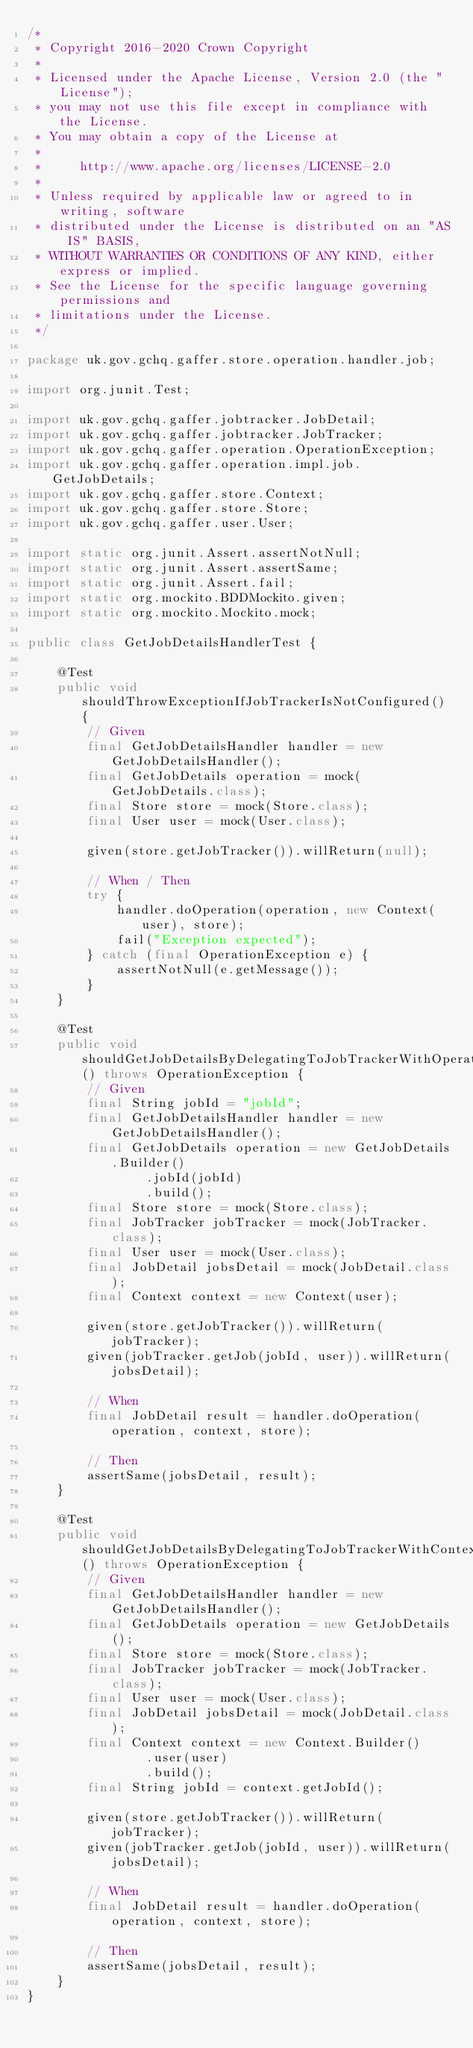Convert code to text. <code><loc_0><loc_0><loc_500><loc_500><_Java_>/*
 * Copyright 2016-2020 Crown Copyright
 *
 * Licensed under the Apache License, Version 2.0 (the "License");
 * you may not use this file except in compliance with the License.
 * You may obtain a copy of the License at
 *
 *     http://www.apache.org/licenses/LICENSE-2.0
 *
 * Unless required by applicable law or agreed to in writing, software
 * distributed under the License is distributed on an "AS IS" BASIS,
 * WITHOUT WARRANTIES OR CONDITIONS OF ANY KIND, either express or implied.
 * See the License for the specific language governing permissions and
 * limitations under the License.
 */

package uk.gov.gchq.gaffer.store.operation.handler.job;

import org.junit.Test;

import uk.gov.gchq.gaffer.jobtracker.JobDetail;
import uk.gov.gchq.gaffer.jobtracker.JobTracker;
import uk.gov.gchq.gaffer.operation.OperationException;
import uk.gov.gchq.gaffer.operation.impl.job.GetJobDetails;
import uk.gov.gchq.gaffer.store.Context;
import uk.gov.gchq.gaffer.store.Store;
import uk.gov.gchq.gaffer.user.User;

import static org.junit.Assert.assertNotNull;
import static org.junit.Assert.assertSame;
import static org.junit.Assert.fail;
import static org.mockito.BDDMockito.given;
import static org.mockito.Mockito.mock;

public class GetJobDetailsHandlerTest {

    @Test
    public void shouldThrowExceptionIfJobTrackerIsNotConfigured() {
        // Given
        final GetJobDetailsHandler handler = new GetJobDetailsHandler();
        final GetJobDetails operation = mock(GetJobDetails.class);
        final Store store = mock(Store.class);
        final User user = mock(User.class);

        given(store.getJobTracker()).willReturn(null);

        // When / Then
        try {
            handler.doOperation(operation, new Context(user), store);
            fail("Exception expected");
        } catch (final OperationException e) {
            assertNotNull(e.getMessage());
        }
    }

    @Test
    public void shouldGetJobDetailsByDelegatingToJobTrackerWithOperationJobId() throws OperationException {
        // Given
        final String jobId = "jobId";
        final GetJobDetailsHandler handler = new GetJobDetailsHandler();
        final GetJobDetails operation = new GetJobDetails.Builder()
                .jobId(jobId)
                .build();
        final Store store = mock(Store.class);
        final JobTracker jobTracker = mock(JobTracker.class);
        final User user = mock(User.class);
        final JobDetail jobsDetail = mock(JobDetail.class);
        final Context context = new Context(user);

        given(store.getJobTracker()).willReturn(jobTracker);
        given(jobTracker.getJob(jobId, user)).willReturn(jobsDetail);

        // When
        final JobDetail result = handler.doOperation(operation, context, store);

        // Then
        assertSame(jobsDetail, result);
    }

    @Test
    public void shouldGetJobDetailsByDelegatingToJobTrackerWithContextJobId() throws OperationException {
        // Given
        final GetJobDetailsHandler handler = new GetJobDetailsHandler();
        final GetJobDetails operation = new GetJobDetails();
        final Store store = mock(Store.class);
        final JobTracker jobTracker = mock(JobTracker.class);
        final User user = mock(User.class);
        final JobDetail jobsDetail = mock(JobDetail.class);
        final Context context = new Context.Builder()
                .user(user)
                .build();
        final String jobId = context.getJobId();

        given(store.getJobTracker()).willReturn(jobTracker);
        given(jobTracker.getJob(jobId, user)).willReturn(jobsDetail);

        // When
        final JobDetail result = handler.doOperation(operation, context, store);

        // Then
        assertSame(jobsDetail, result);
    }
}
</code> 